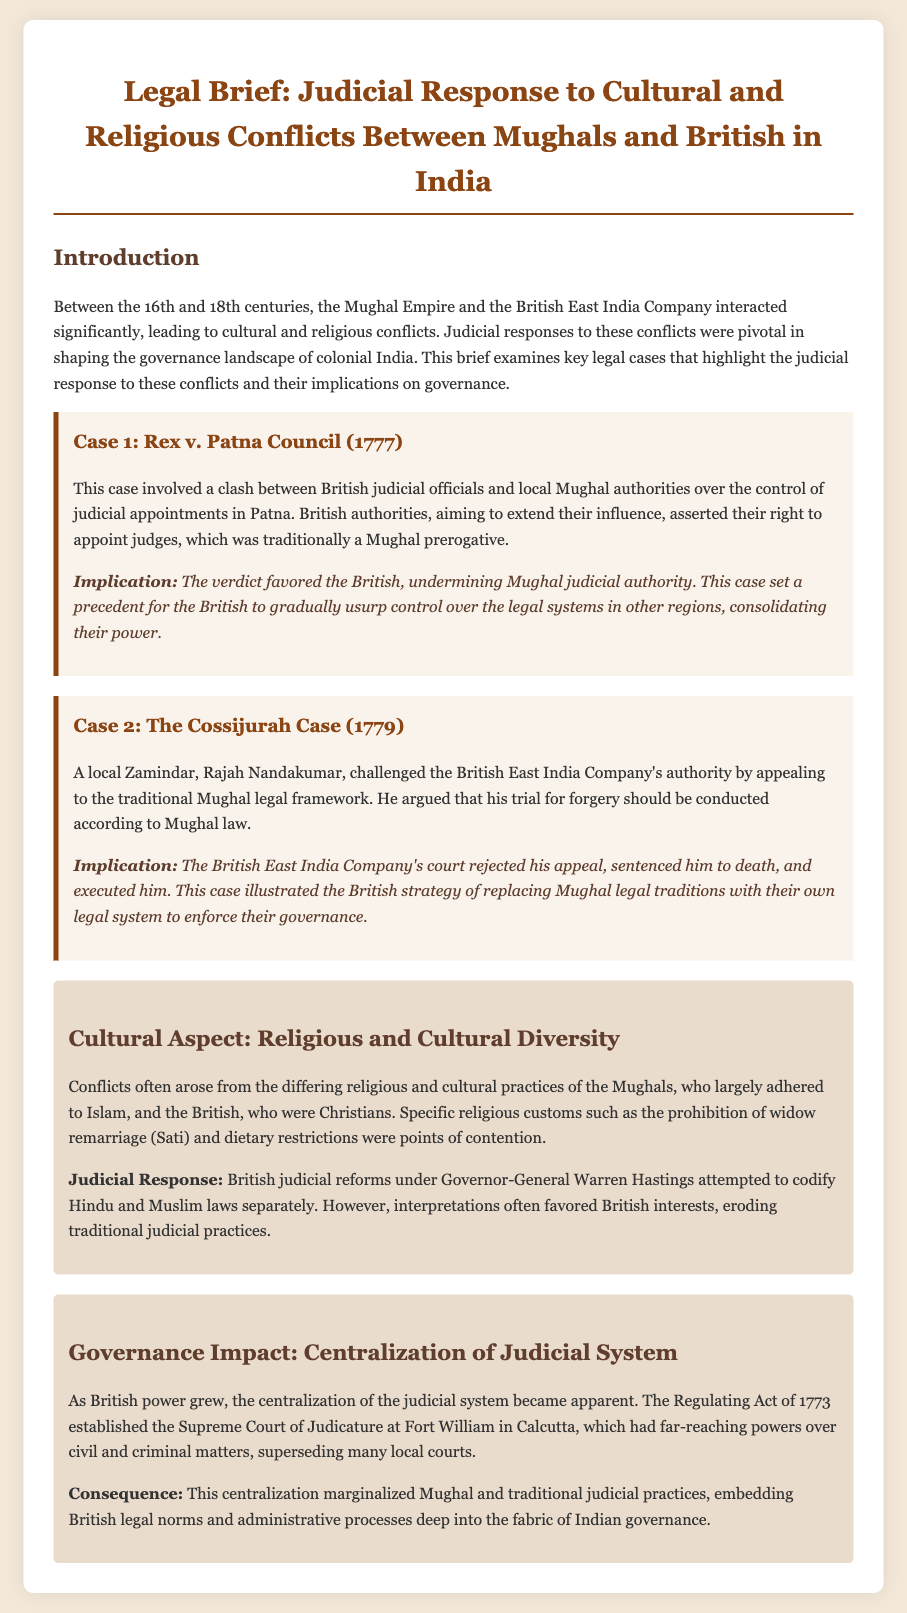What was the year of the Rex v. Patna Council case? The document states that Rex v. Patna Council occurred in 1777.
Answer: 1777 What did the British authorities assert in the Rex v. Patna Council case? The British authorities asserted their right to appoint judges, traditionally a Mughal prerogative.
Answer: Right to appoint judges Who was the local zamindar in The Cossijurah Case? The document mentions that Rajah Nandakumar was the local zamindar.
Answer: Rajah Nandakumar What was the outcome of The Cossijurah Case? The British East India Company's court rejected the appeal and sentenced Rajah Nandakumar to death.
Answer: Sentenced to death What significant legal reform did Governor-General Warren Hastings attempt? The document mentions that he attempted to codify Hindu and Muslim laws separately.
Answer: Codify laws separately What was the consequence of the centralization of the judicial system? The centralization marginalized Mughal and traditional judicial practices.
Answer: Marginalized Mughal practices What established the Supreme Court of Judicature at Fort William? The Regulating Act of 1773 established the Supreme Court of Judicature.
Answer: Regulating Act of 1773 What was a key cultural conflict between the Mughals and the British? One key cultural conflict was regarding the prohibition of widow remarriage (Sati).
Answer: Prohibition of widow remarriage 